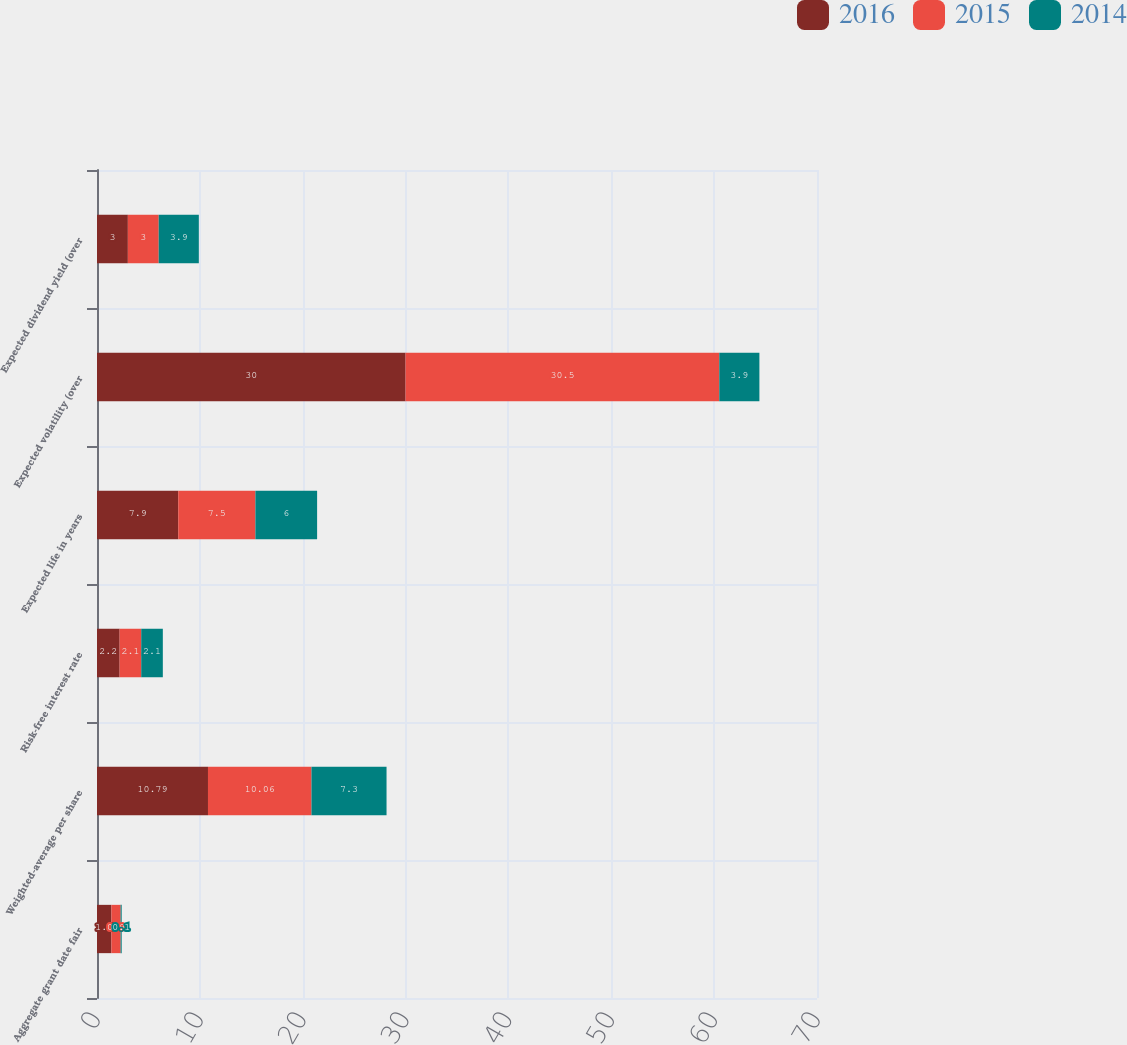Convert chart. <chart><loc_0><loc_0><loc_500><loc_500><stacked_bar_chart><ecel><fcel>Aggregate grant date fair<fcel>Weighted-average per share<fcel>Risk-free interest rate<fcel>Expected life in years<fcel>Expected volatility (over<fcel>Expected dividend yield (over<nl><fcel>2016<fcel>1.4<fcel>10.79<fcel>2.2<fcel>7.9<fcel>30<fcel>3<nl><fcel>2015<fcel>0.9<fcel>10.06<fcel>2.1<fcel>7.5<fcel>30.5<fcel>3<nl><fcel>2014<fcel>0.1<fcel>7.3<fcel>2.1<fcel>6<fcel>3.9<fcel>3.9<nl></chart> 